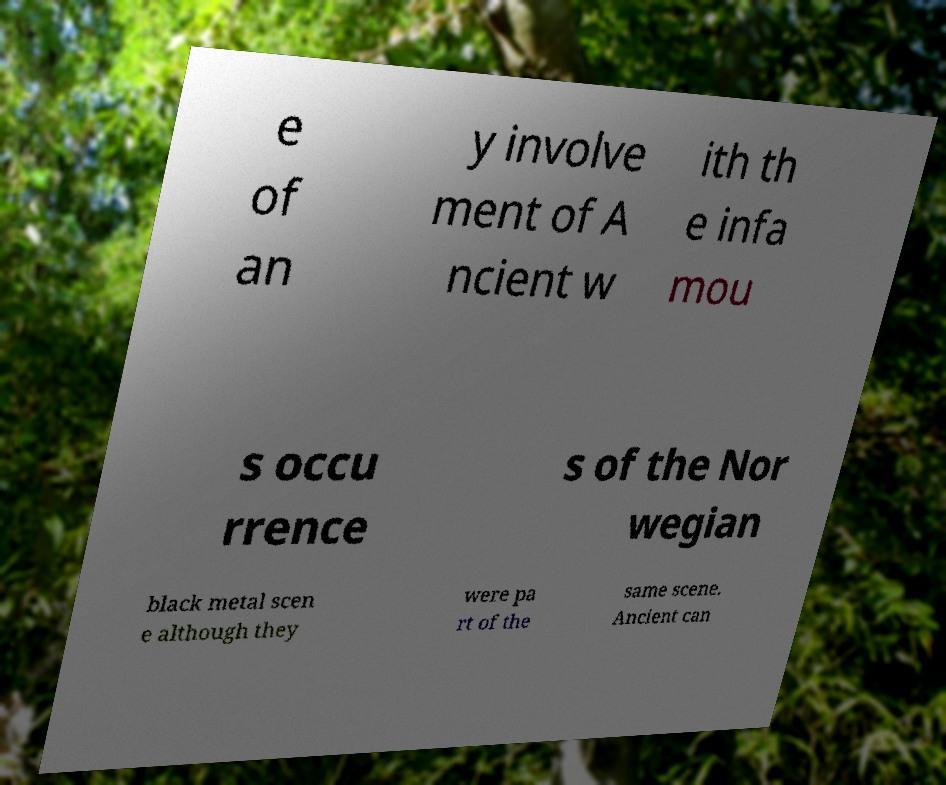Can you accurately transcribe the text from the provided image for me? e of an y involve ment of A ncient w ith th e infa mou s occu rrence s of the Nor wegian black metal scen e although they were pa rt of the same scene. Ancient can 